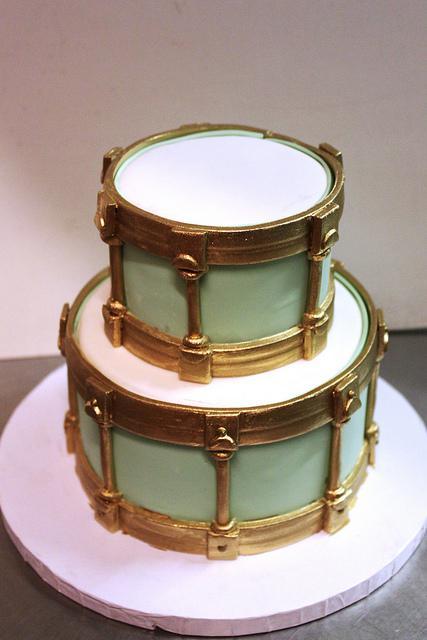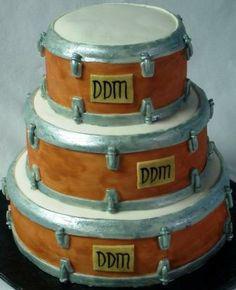The first image is the image on the left, the second image is the image on the right. Analyze the images presented: Is the assertion "One cake features a drum kit on the top, and the other cake features drum sticks on top of the base layer of the cake." valid? Answer yes or no. No. The first image is the image on the left, the second image is the image on the right. Given the left and right images, does the statement "Both cakes are tiered." hold true? Answer yes or no. Yes. 